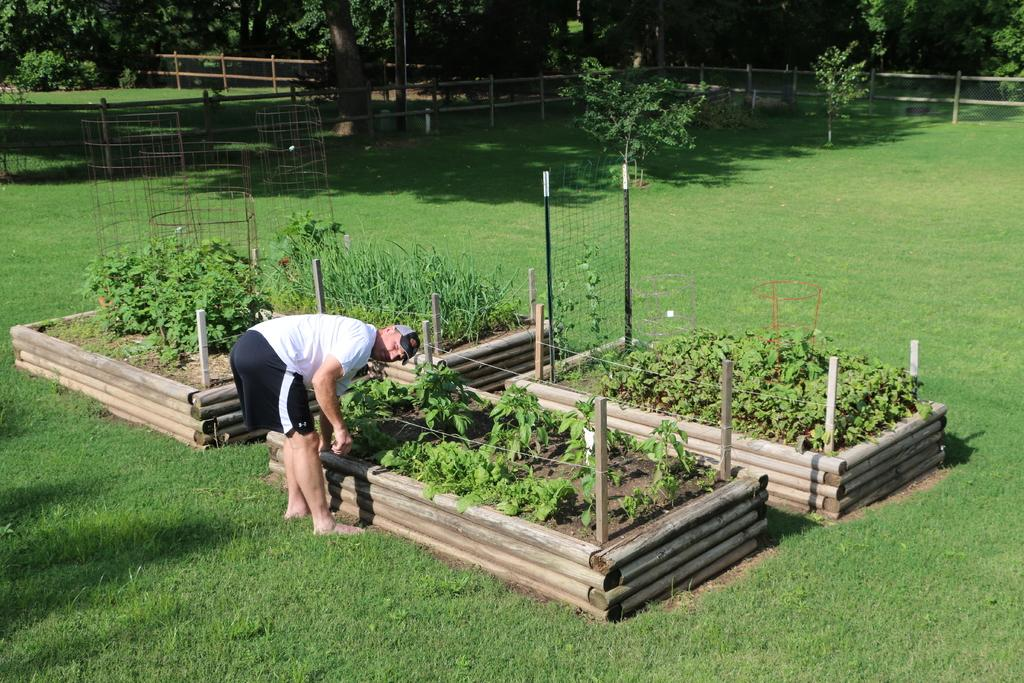Who is present in the image? There is a man in the image. What is the man wearing? The man is wearing a white t-shirt. Where is the man standing? The man is standing on the grass. What can be seen in front of the man? There are plants, trees, and fences in front of the man. What type of drawer can be seen in the image? There is no drawer present in the image. How many basins are visible in the image? There are no basins visible in the image. 